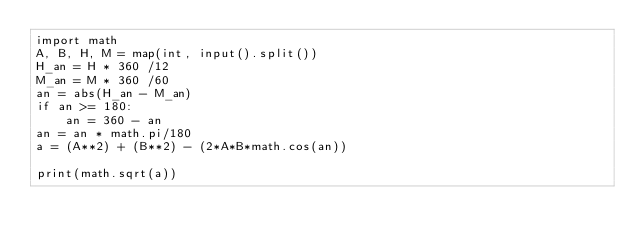Convert code to text. <code><loc_0><loc_0><loc_500><loc_500><_Python_>import math
A, B, H, M = map(int, input().split())
H_an = H * 360 /12
M_an = M * 360 /60
an = abs(H_an - M_an)
if an >= 180:
    an = 360 - an
an = an * math.pi/180
a = (A**2) + (B**2) - (2*A*B*math.cos(an))

print(math.sqrt(a))</code> 